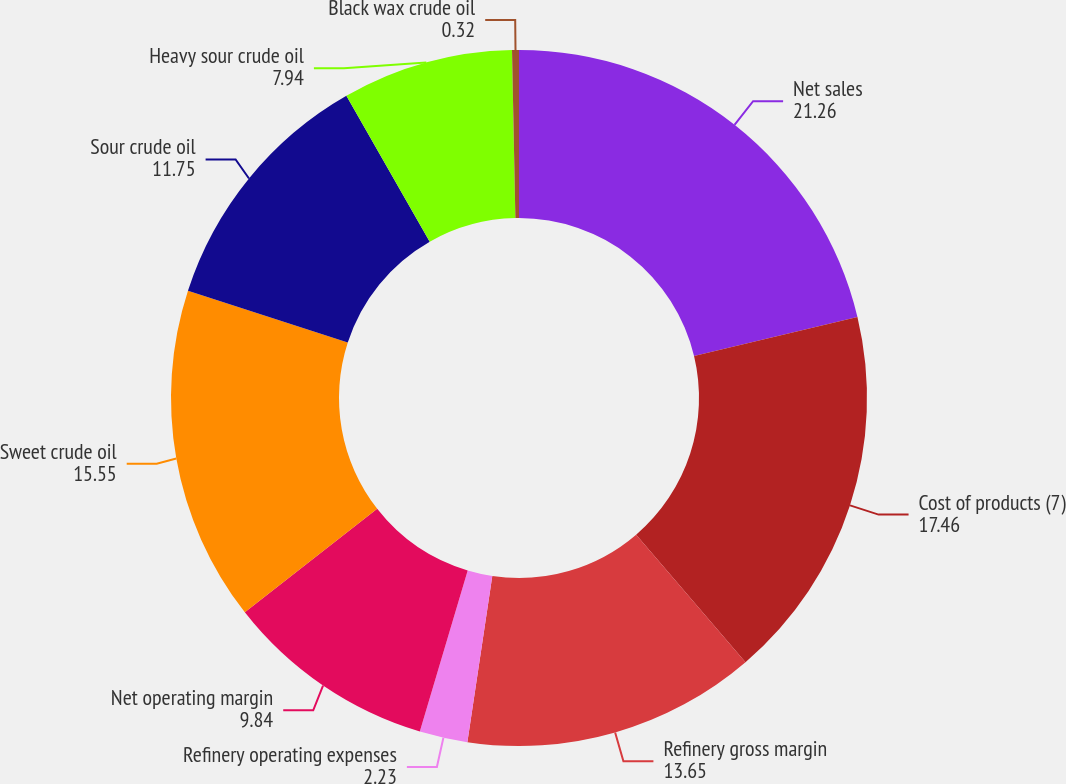Convert chart to OTSL. <chart><loc_0><loc_0><loc_500><loc_500><pie_chart><fcel>Net sales<fcel>Cost of products (7)<fcel>Refinery gross margin<fcel>Refinery operating expenses<fcel>Net operating margin<fcel>Sweet crude oil<fcel>Sour crude oil<fcel>Heavy sour crude oil<fcel>Black wax crude oil<nl><fcel>21.26%<fcel>17.46%<fcel>13.65%<fcel>2.23%<fcel>9.84%<fcel>15.55%<fcel>11.75%<fcel>7.94%<fcel>0.32%<nl></chart> 